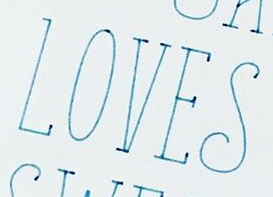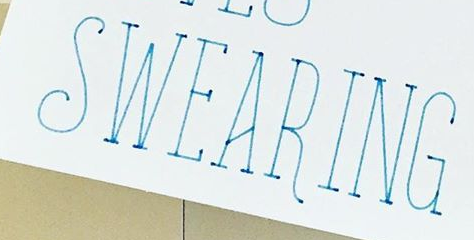Transcribe the words shown in these images in order, separated by a semicolon. LOVES; SWEARING 